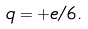<formula> <loc_0><loc_0><loc_500><loc_500>q = + e / 6 .</formula> 